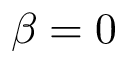Convert formula to latex. <formula><loc_0><loc_0><loc_500><loc_500>\beta = 0</formula> 